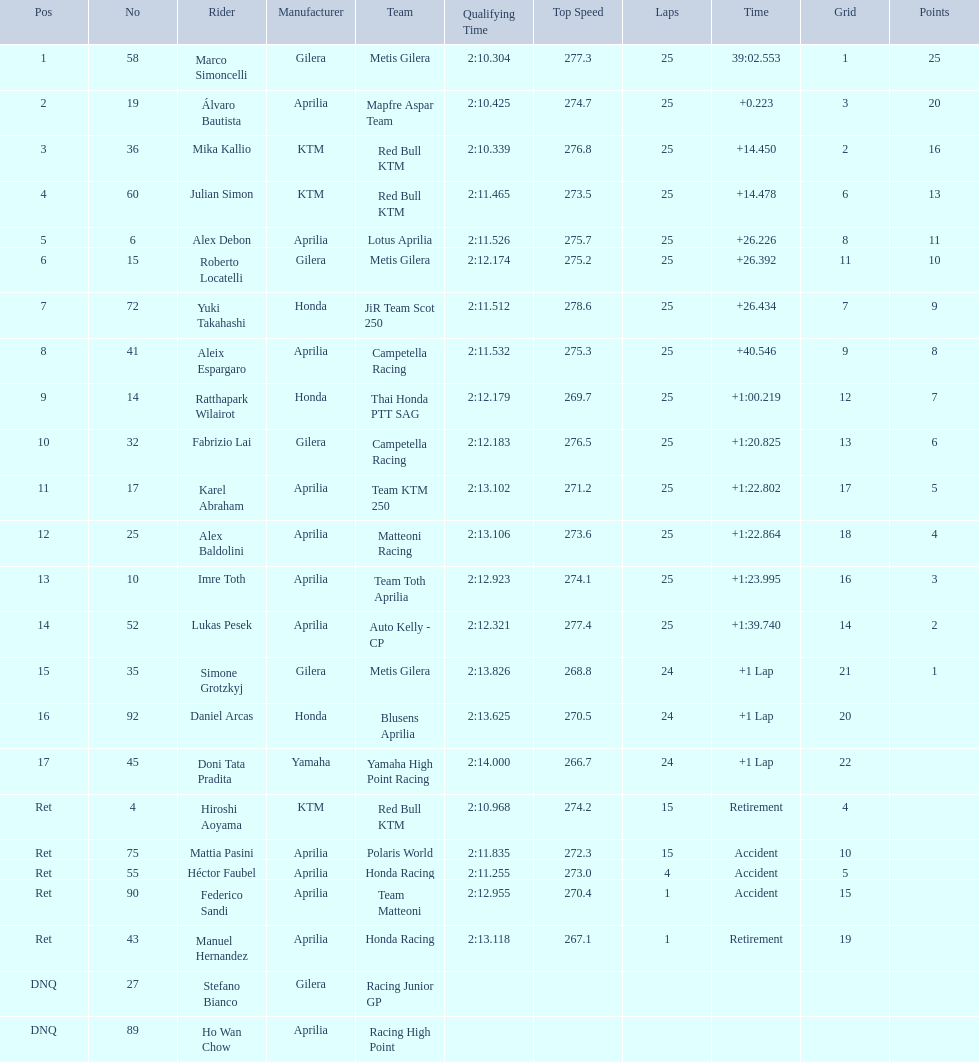How many laps did hiroshi aoyama perform? 15. How many laps did marco simoncelli perform? 25. Who performed more laps out of hiroshi aoyama and marco 
simoncelli? Marco Simoncelli. 